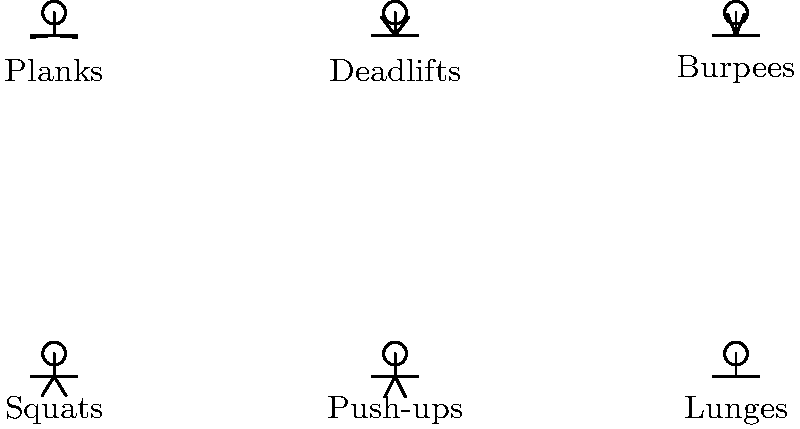Based on the stick figure illustrations, which exercise is most effective for overall body strength and muscle engagement, considering its compound nature and involvement of multiple muscle groups? To determine the most effective exercise for overall body strength and muscle engagement, we need to analyze each exercise based on its compound nature and the number of muscle groups involved:

1. Squats: Engages multiple large muscle groups including quadriceps, hamstrings, glutes, and core. It's a compound movement that also improves overall stability.

2. Push-ups: Primarily targets chest, triceps, and shoulders, with some core engagement. It's a compound upper body exercise.

3. Lunges: Works legs, glutes, and core, improving balance and stability. It's a unilateral exercise that addresses muscle imbalances.

4. Planks: Primarily engages core muscles, with some shoulder and back involvement. It's an isometric exercise.

5. Deadlifts: Engages the most muscle groups, including legs, back, core, and arms. It's a highly compound movement that mimics many real-life lifting situations.

6. Burpees: A full-body exercise that combines a push-up, squat, and jump. It engages multiple muscle groups and provides cardiovascular benefits.

Among these exercises, deadlifts stand out as the most effective for overall body strength and muscle engagement. They involve the largest number of muscle groups, require compound movement patterns, and closely resemble functional, real-world movements. Deadlifts also allow for progressive overload, which is crucial for long-term strength gains and muscle development.
Answer: Deadlifts 